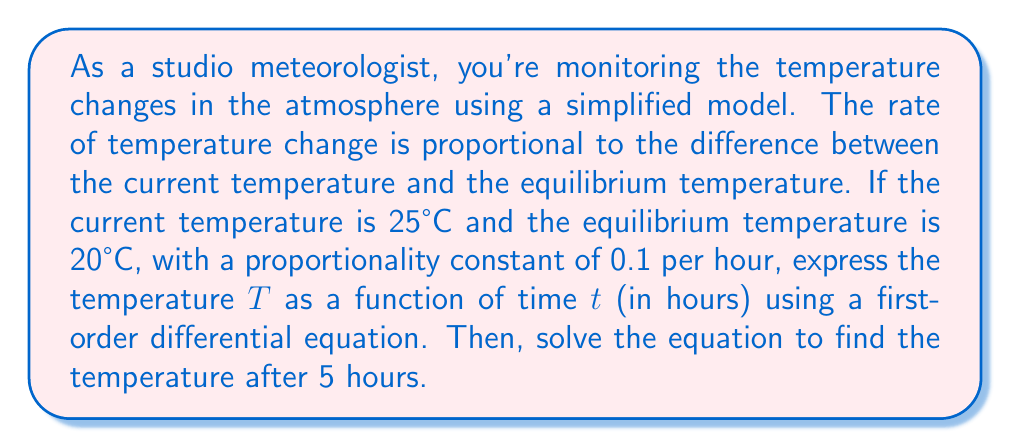Give your solution to this math problem. Let's approach this step-by-step:

1) First, we need to set up our differential equation. The rate of change of temperature with respect to time is proportional to the difference between the current temperature and the equilibrium temperature:

   $$\frac{dT}{dt} = -k(T - T_e)$$

   where $k$ is the proportionality constant, $T$ is the current temperature, and $T_e$ is the equilibrium temperature.

2) We're given:
   - Initial temperature $T_0 = 25°C$
   - Equilibrium temperature $T_e = 20°C$
   - Proportionality constant $k = 0.1$ per hour

3) Substituting these values into our equation:

   $$\frac{dT}{dt} = -0.1(T - 20)$$

4) To solve this differential equation, we can use separation of variables:

   $$\frac{dT}{T - 20} = -0.1dt$$

5) Integrating both sides:

   $$\int \frac{dT}{T - 20} = -0.1 \int dt$$
   
   $$\ln|T - 20| = -0.1t + C$$

6) Using the initial condition $T = 25$ when $t = 0$:

   $$\ln|25 - 20| = C$$
   $$C = \ln 5$$

7) Substituting back:

   $$\ln|T - 20| = -0.1t + \ln 5$$

8) Solving for T:

   $$T - 20 = 5e^{-0.1t}$$
   $$T = 20 + 5e^{-0.1t}$$

9) This is our general solution. To find the temperature after 5 hours, we substitute $t = 5$:

   $$T = 20 + 5e^{-0.1(5)} = 20 + 5e^{-0.5} \approx 23.03°C$$
Answer: The temperature after 5 hours will be approximately 23.03°C. 